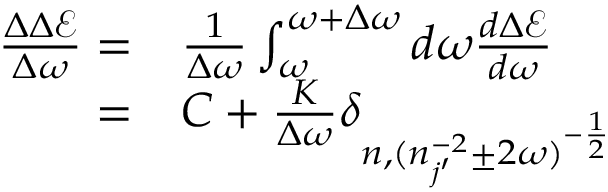<formula> <loc_0><loc_0><loc_500><loc_500>\begin{array} { r l } { \frac { \Delta \Delta \mathcal { E } } { \Delta \omega } = } & \frac { 1 } { \Delta \omega } \int _ { \omega } ^ { \omega + \Delta \omega } d \omega \frac { d \Delta \mathcal { E } } { d \omega } } \\ { = } & C + \frac { K } { \Delta \omega } \delta _ { n , ( n _ { j ^ { \prime } } ^ { - 2 } \pm 2 \omega ) ^ { - \frac { 1 } { 2 } } } } \end{array}</formula> 